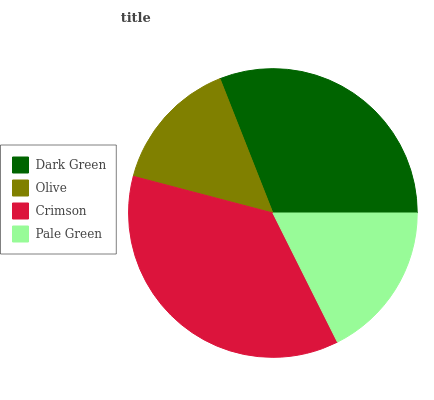Is Olive the minimum?
Answer yes or no. Yes. Is Crimson the maximum?
Answer yes or no. Yes. Is Crimson the minimum?
Answer yes or no. No. Is Olive the maximum?
Answer yes or no. No. Is Crimson greater than Olive?
Answer yes or no. Yes. Is Olive less than Crimson?
Answer yes or no. Yes. Is Olive greater than Crimson?
Answer yes or no. No. Is Crimson less than Olive?
Answer yes or no. No. Is Dark Green the high median?
Answer yes or no. Yes. Is Pale Green the low median?
Answer yes or no. Yes. Is Olive the high median?
Answer yes or no. No. Is Dark Green the low median?
Answer yes or no. No. 